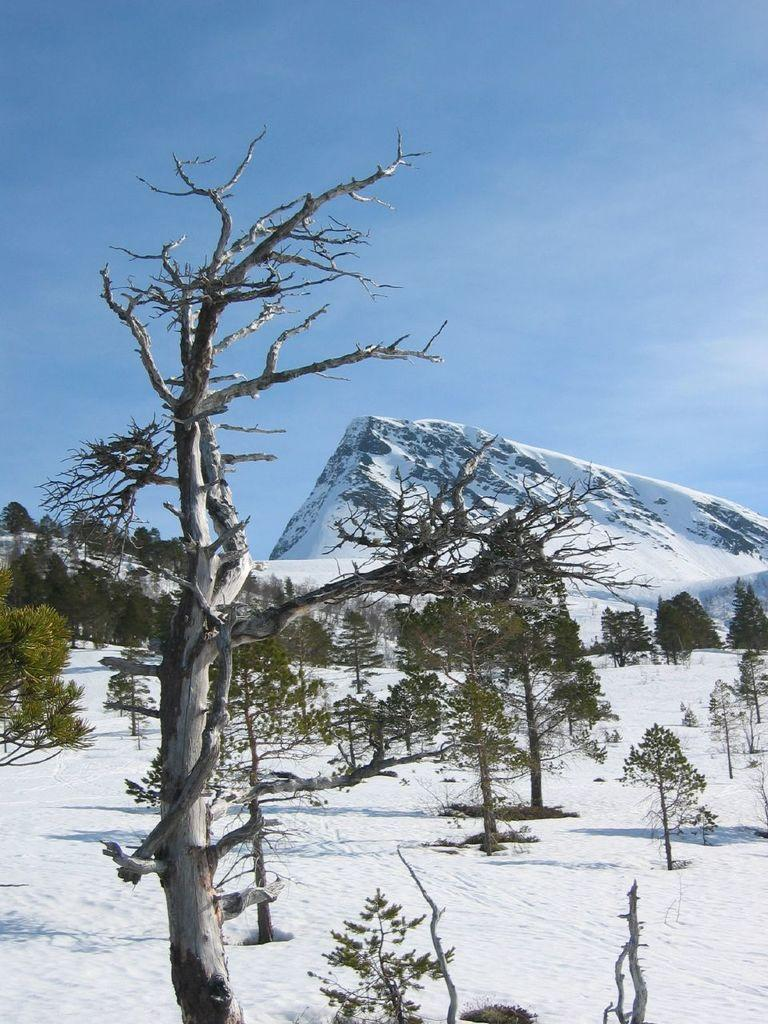What type of vegetation can be seen in the image? There are trees in the image. What geographical features are present in the image? There are hills in the image. What weather condition is depicted in the image? There is snow visible in the image. What type of meat is being grilled in the image? There is no meat or grill present in the image. What month is it in the image? The month cannot be determined from the image, as there are no specific time indicators present. 